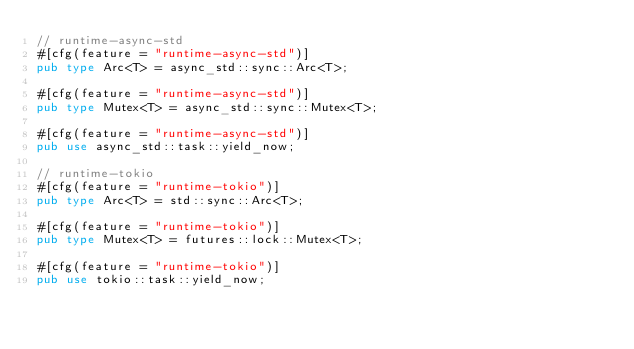<code> <loc_0><loc_0><loc_500><loc_500><_Rust_>// runtime-async-std
#[cfg(feature = "runtime-async-std")]
pub type Arc<T> = async_std::sync::Arc<T>;

#[cfg(feature = "runtime-async-std")]
pub type Mutex<T> = async_std::sync::Mutex<T>;

#[cfg(feature = "runtime-async-std")]
pub use async_std::task::yield_now;

// runtime-tokio
#[cfg(feature = "runtime-tokio")]
pub type Arc<T> = std::sync::Arc<T>;

#[cfg(feature = "runtime-tokio")]
pub type Mutex<T> = futures::lock::Mutex<T>;

#[cfg(feature = "runtime-tokio")]
pub use tokio::task::yield_now;
</code> 